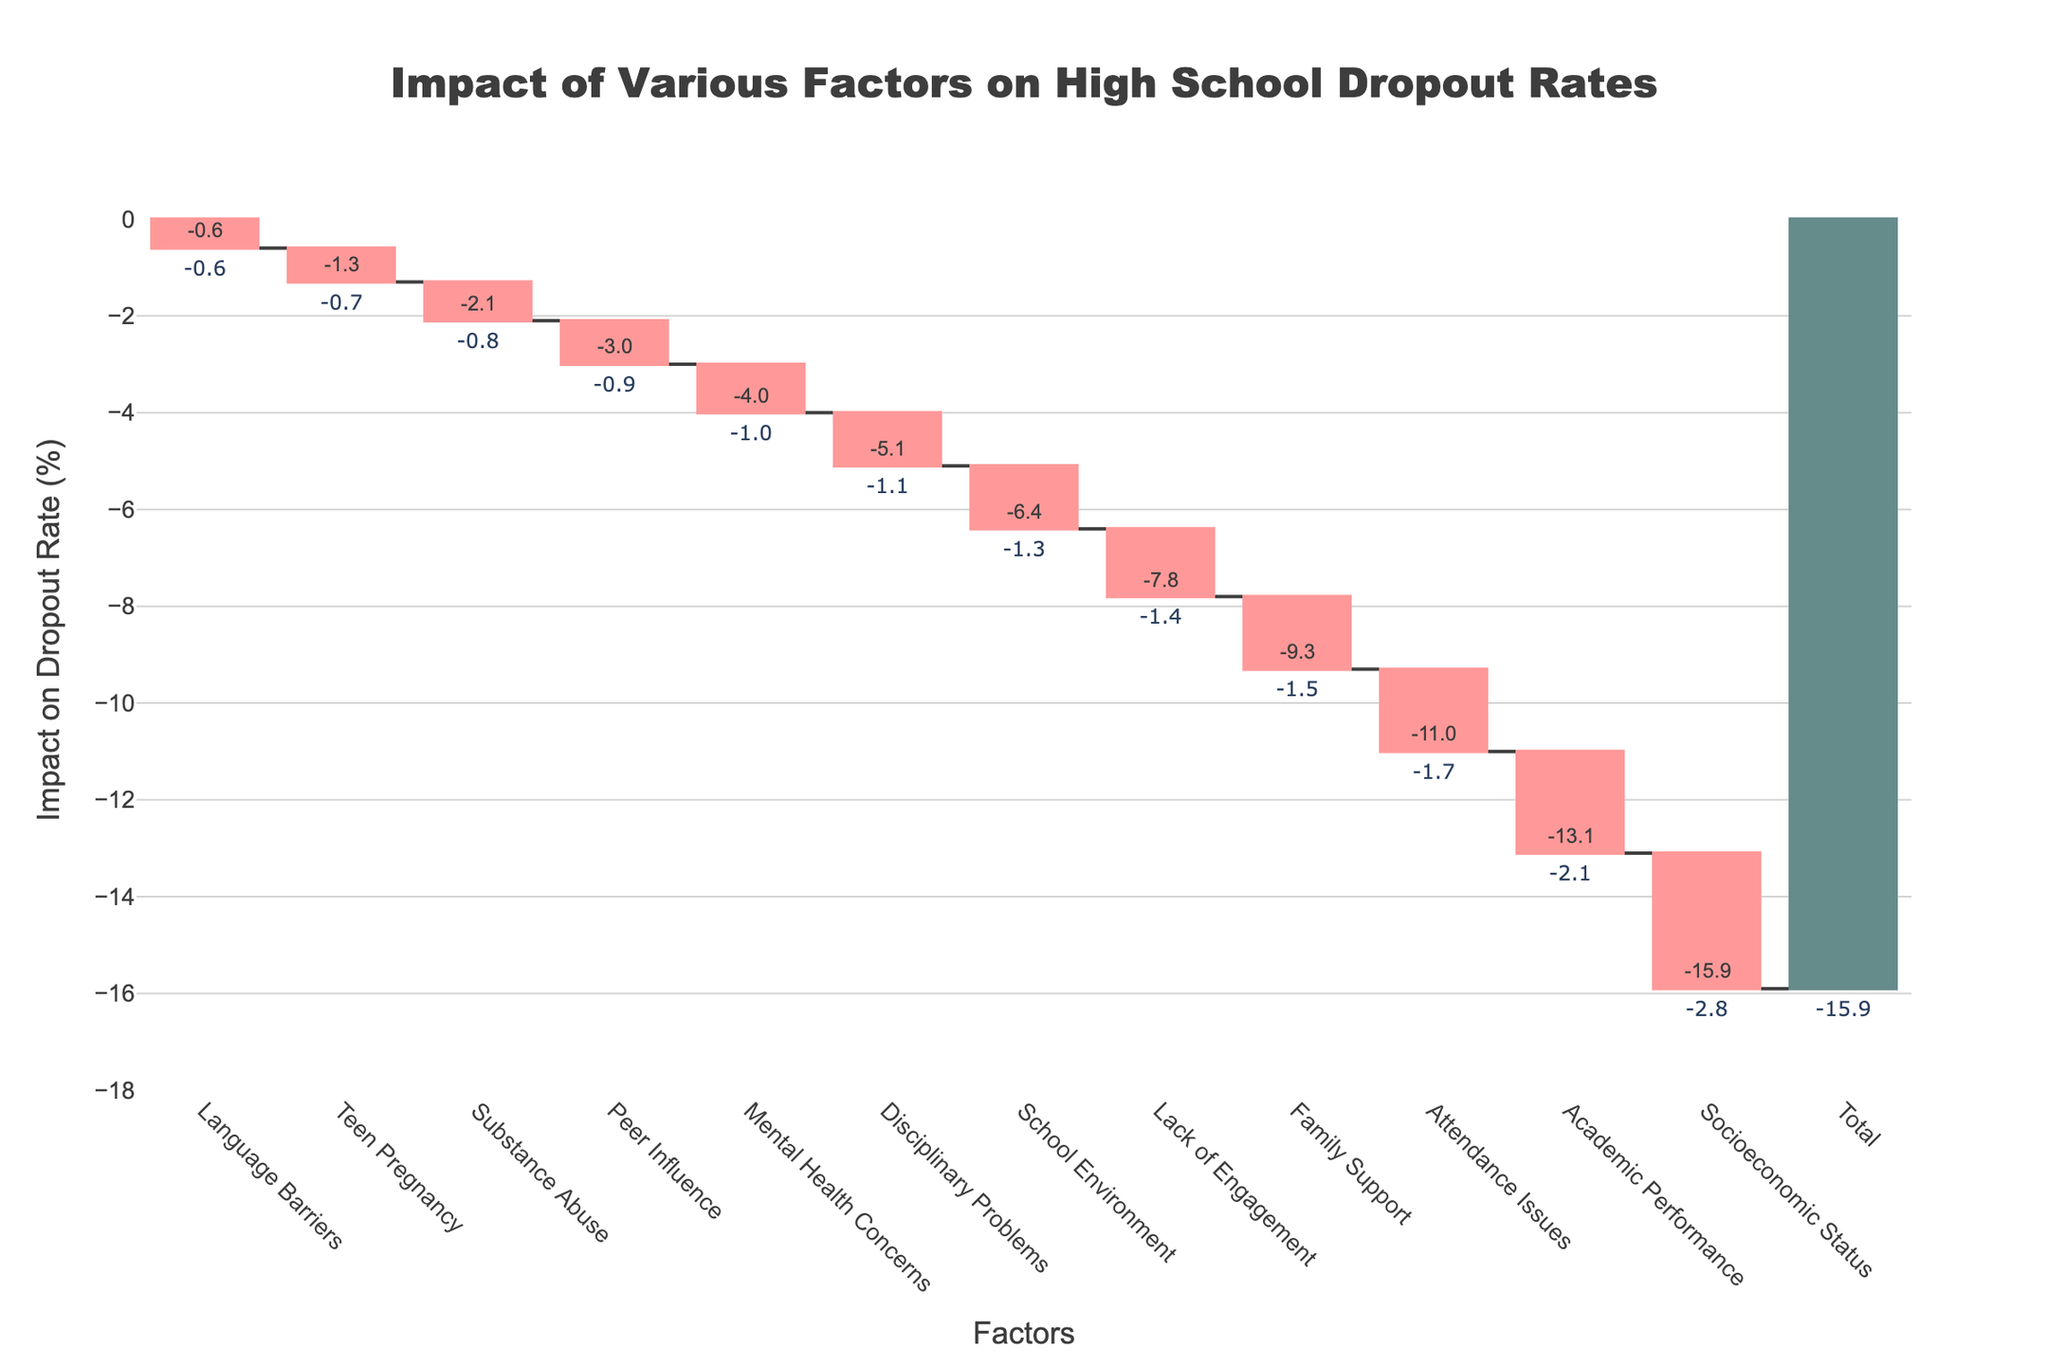What is the overall title of the chart? The chart's title is usually placed at the top center of the figure. In this case, it reads "Impact of Various Factors on High School Dropout Rates".
Answer: Impact of Various Factors on High School Dropout Rates Which factor has the largest negative impact on dropout rates? By looking at the heights of the bars, the tallest bar extending downwards represents the factor with the largest impact. In this chart, "Socioeconomic Status" has the largest negative impact.
Answer: Socioeconomic Status How much does family support contribute to reducing dropout rates? Next to the bar labeled "Family Support," the value given is crucial for understanding its impact. The chart shows a value of -1.5 for Family Support.
Answer: -1.5% What is the cumulative impact of the three factors with the greatest negative impact? First, identify the three factors: "Socioeconomic Status" (-2.8), "Academic Performance" (-2.1), and "Attendance Issues" (-1.7). Sum these to find the cumulative impact: -2.8 - 2.1 - 1.7 = -6.6.
Answer: -6.6% Which factor has the least impact on dropout rates? By observing the smallest bar, which is closest to zero, "Language Barriers" has the least impact with a value of -0.6.
Answer: Language Barriers What is the cumulative impact after "School Environment"? Find "School Environment" and check its cumulative value at that point. According to the annotations, up to "School Environment" the cumulative impact is -5.3.
Answer: -5.3% How does the impact of "Peer Influence" compare to "Attendance Issues"? Locate the bars for "Peer Influence" (-0.9) and "Attendance Issues" (-1.7). Since -1.7 < -0.9, "Attendance Issues" have a greater negative impact than "Peer Influence".
Answer: Attendance Issues have a greater negative impact What is the total cumulative impact of all factors? The grand total is given at the end of the chart, which is summed up and provided as the final cumulative impact. The chart states that the total impact is -15.9.
Answer: -15.9% Among the listed factors, which ones have an impact between -1 and -1.5? By examining the chart, "Family Support" (-1.5), "Attendance Issues" (-1.7), "Lack of Engagement" (-1.4), "Disciplinary Problems" (-1.1), and "Mental Health Concerns" (-1.0) fall within or near this range.
Answer: Family Support, Lack of Engagement, Disciplinary Problems, Mental Health Concerns If "Socioeconomic Status" was improved to have no impact on dropout rates, what would the new total cumulative impact be? The current total impact is -15.9. If "Socioeconomic Status," which has an impact of -2.8, was improved to zero, the new total would be -15.9 + 2.8 = -13.1.
Answer: -13.1% 